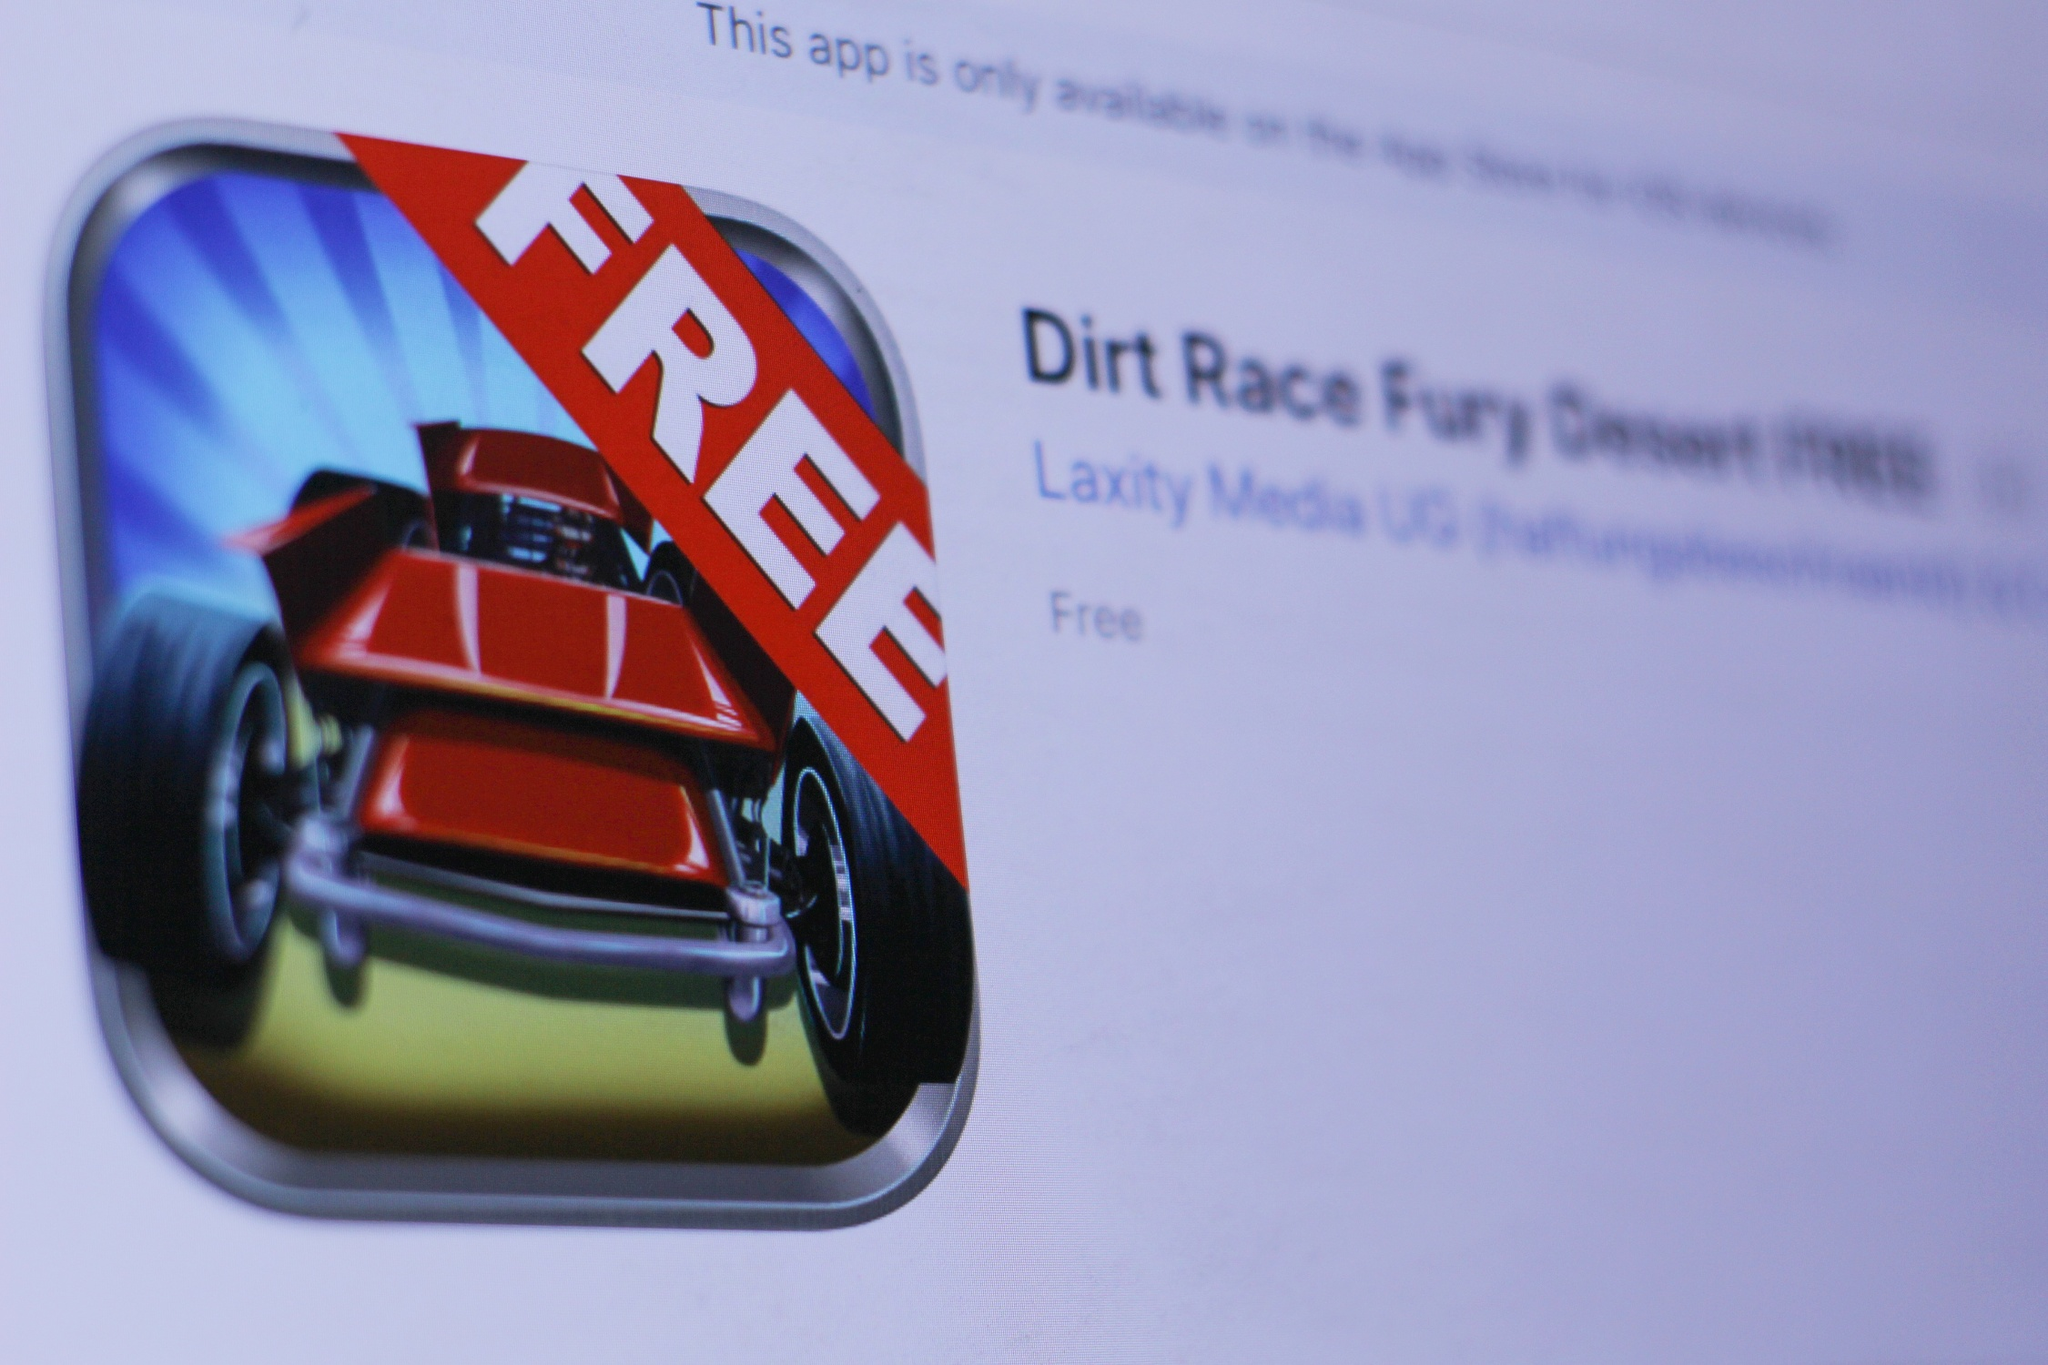Can you describe the primary visual features of this app's icon? The primary visual features of the app's icon include a dynamic red car that appears to be racing forward, set against a vibrant blue background with contrasting white rays. A bold red banner with the word 'FREE' in white text slashes across the icon diagonally, emphasizing the app’s cost-free availability. This dramatic and colorful design aims to catch the viewer's eye while clearly communicating the app's free status. What kind of audience might be interested in downloading this app? Given the fast car and racing themes evident in the app icon, the application 'Dirt Race Fury Desert FREE' is likely to attract an audience that enjoys high-speed racing games. This could include young adults and teenagers, especially those who appreciate thrilling and competitive driving experiences in digital environments. The eye-catching and dynamic visuals, combined with the 'FREE' label, would also appeal to budget-conscious gamers looking for excitement without the cost. Imagine a scenario where a user plays this game. What might their experience be like? On launching 'Dirt Race Fury Desert FREE', the user is greeted with intense, high-energy music that sets the tone for the gameplay. The interface is sleek and easy to navigate, promptly dropping the player into a fast-paced desert racing track. The user grips their device as their red car hurtles across dusty dunes, kicking up sand and dodging obstacles at breakneck speeds. The game's responsive controls and realistic graphics immerse the player, making every twist and turn feel exhilarating. They might find themselves constantly pushing for higher speeds and better lap times, competing against their own best scores or online leaderboards. Despite the simplicity suggested by 'FREE', the game's engaging challenges and detail ensure a rewarding and addictive experience. What if this image told a completely different story, beyond just the app details? Get creative! Imagine a world where race cars are not just vehicles but heroes of an ancient prophecy. This app icon is the gateway to a fantastical realm called 'Racer's Eden,' where each car is imbued with mystical powers. The fiery red car depicted on the icon is 'Blaze,' a legendary vehicle known for its ability to manipulate time. Players must navigate through the 'Desert of Echoes,' where every race isn't just a competition but a battle against demonic mirages that try to derail Blaze from its quest. The 'FREE' banner isn't just a pricing detail—it symbolizes that anyone who dares can join the resistance against the shadow forces controlling the desert. By racing through various challenges, users not only enjoy an adrenaline-pumping experience but also help Blaze uncover the lost secrets of Racer's Eden, ultimately becoming a hero in their own right. 